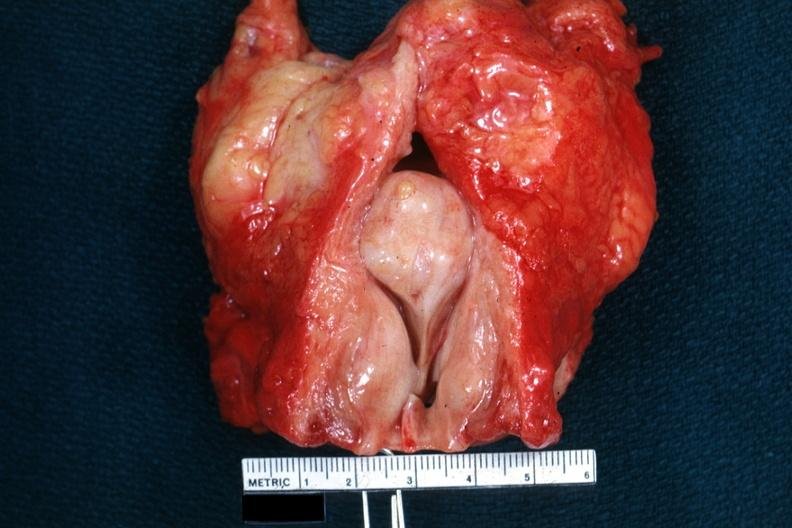what does not show bladder well?
Answer the question using a single word or phrase. So-called median bar 